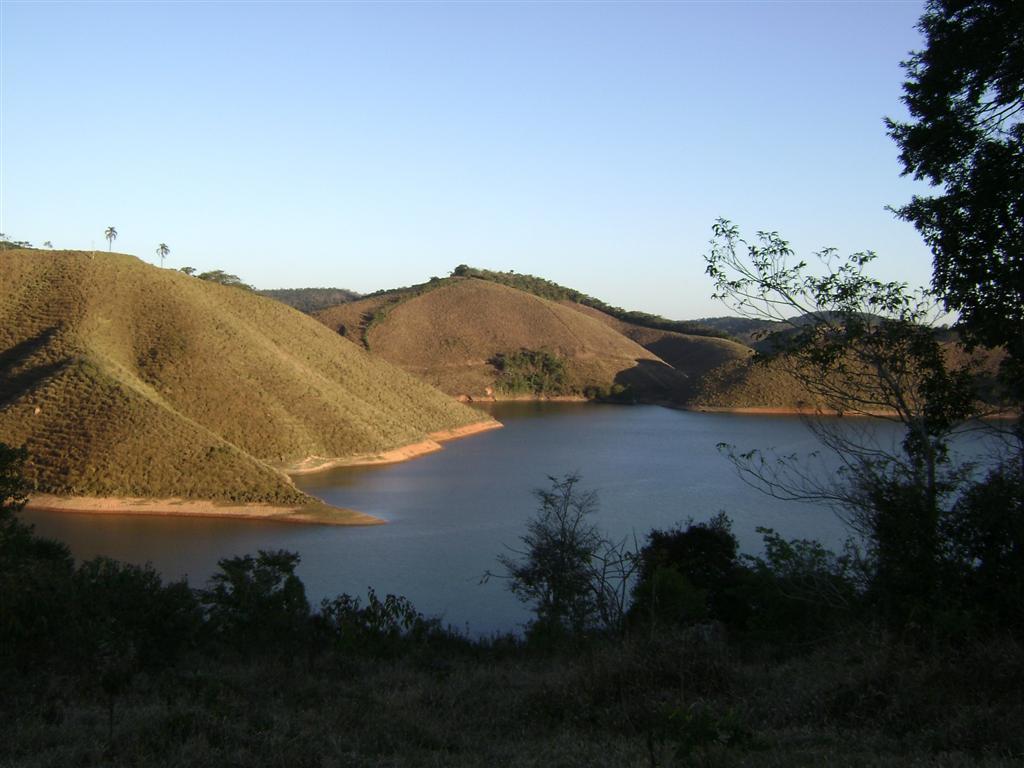Can you describe this image briefly? This is water. There are plants, trees, and mountain. In the background there is sky. 